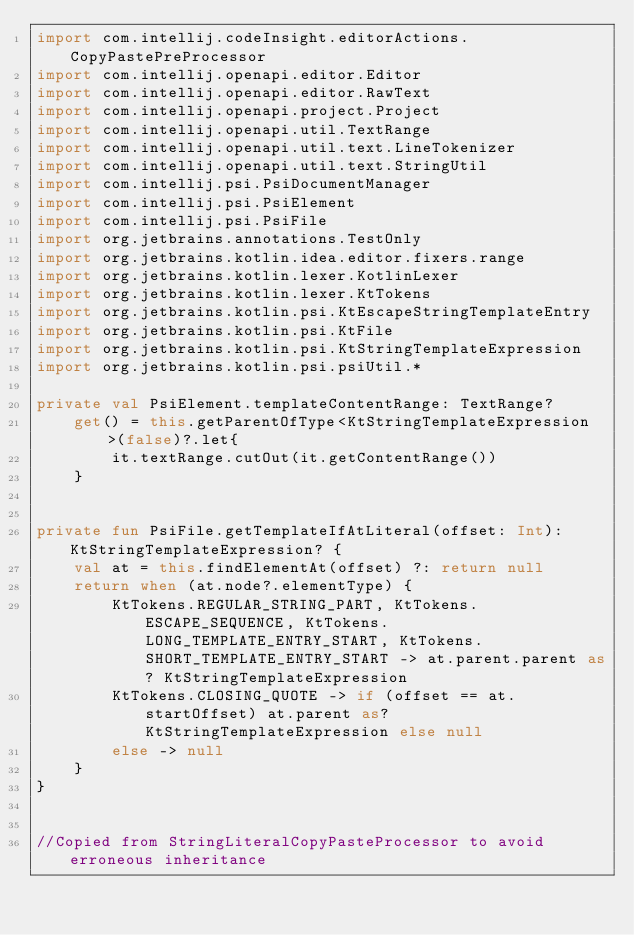<code> <loc_0><loc_0><loc_500><loc_500><_Kotlin_>import com.intellij.codeInsight.editorActions.CopyPastePreProcessor
import com.intellij.openapi.editor.Editor
import com.intellij.openapi.editor.RawText
import com.intellij.openapi.project.Project
import com.intellij.openapi.util.TextRange
import com.intellij.openapi.util.text.LineTokenizer
import com.intellij.openapi.util.text.StringUtil
import com.intellij.psi.PsiDocumentManager
import com.intellij.psi.PsiElement
import com.intellij.psi.PsiFile
import org.jetbrains.annotations.TestOnly
import org.jetbrains.kotlin.idea.editor.fixers.range
import org.jetbrains.kotlin.lexer.KotlinLexer
import org.jetbrains.kotlin.lexer.KtTokens
import org.jetbrains.kotlin.psi.KtEscapeStringTemplateEntry
import org.jetbrains.kotlin.psi.KtFile
import org.jetbrains.kotlin.psi.KtStringTemplateExpression
import org.jetbrains.kotlin.psi.psiUtil.*

private val PsiElement.templateContentRange: TextRange?
    get() = this.getParentOfType<KtStringTemplateExpression>(false)?.let{
        it.textRange.cutOut(it.getContentRange())
    }


private fun PsiFile.getTemplateIfAtLiteral(offset: Int): KtStringTemplateExpression? {
    val at = this.findElementAt(offset) ?: return null
    return when (at.node?.elementType) {
        KtTokens.REGULAR_STRING_PART, KtTokens.ESCAPE_SEQUENCE, KtTokens.LONG_TEMPLATE_ENTRY_START, KtTokens.SHORT_TEMPLATE_ENTRY_START -> at.parent.parent as? KtStringTemplateExpression
        KtTokens.CLOSING_QUOTE -> if (offset == at.startOffset) at.parent as? KtStringTemplateExpression else null
        else -> null
    }
}


//Copied from StringLiteralCopyPasteProcessor to avoid erroneous inheritance</code> 